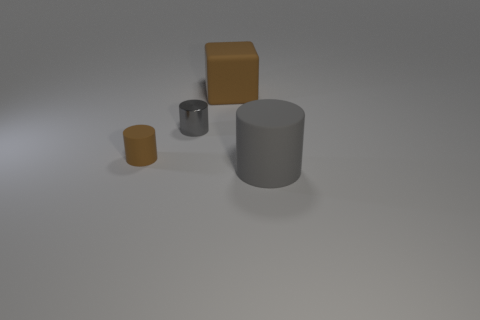What number of other objects are the same color as the small metallic thing?
Offer a terse response. 1. Is the large block made of the same material as the gray object on the left side of the brown block?
Keep it short and to the point. No. How many big objects are there?
Your response must be concise. 2. There is a rubber cylinder that is on the right side of the tiny metallic cylinder; what is its size?
Offer a terse response. Large. What number of other rubber cylinders have the same size as the brown cylinder?
Ensure brevity in your answer.  0. There is a object that is both behind the brown cylinder and in front of the big brown rubber object; what is its material?
Your answer should be very brief. Metal. What is the material of the object that is the same size as the brown matte cylinder?
Your response must be concise. Metal. What is the size of the brown thing that is to the right of the matte thing to the left of the large matte object that is behind the gray matte object?
Offer a terse response. Large. There is a block that is made of the same material as the big gray thing; what is its size?
Provide a short and direct response. Large. Is the size of the brown block the same as the brown matte object that is to the left of the large brown object?
Give a very brief answer. No. 